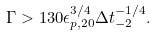<formula> <loc_0><loc_0><loc_500><loc_500>\Gamma > 1 3 0 \epsilon _ { p , 2 0 } ^ { 3 / 4 } \Delta t ^ { - 1 / 4 } _ { - 2 } .</formula> 